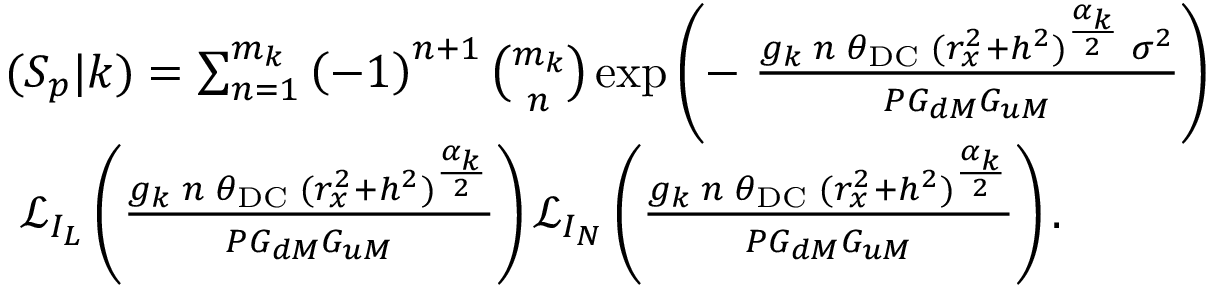<formula> <loc_0><loc_0><loc_500><loc_500>\begin{array} { r l } & { \, ( S _ { p } | k ) = \sum _ { n = 1 } ^ { m _ { k } } \left ( - 1 \right ) ^ { n + 1 } { \binom { m _ { k } } { n } } \exp \left ( - \, \frac { g _ { k } \, n \, \theta _ { D C } \, ( r _ { x } ^ { 2 } + h ^ { 2 } ) ^ { \frac { \alpha _ { k } } { 2 } } \, \sigma ^ { 2 } } { P G _ { d M } G _ { u M } } \right ) } \\ { \, } & { \mathcal { L } _ { I _ { L } } \left ( \frac { g _ { k } \, n \, \theta _ { D C } \, ( r _ { x } ^ { 2 } + h ^ { 2 } ) ^ { \frac { \alpha _ { k } } { 2 } } } { P G _ { d M } G _ { u M } } \right ) \mathcal { L } _ { I _ { N } } \left ( \frac { g _ { k } \, n \, \theta _ { D C } \, ( r _ { x } ^ { 2 } + h ^ { 2 } ) ^ { \frac { \alpha _ { k } } { 2 } } } { P G _ { d M } G _ { u M } } \right ) . } \end{array}</formula> 